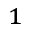<formula> <loc_0><loc_0><loc_500><loc_500>_ { 1 }</formula> 